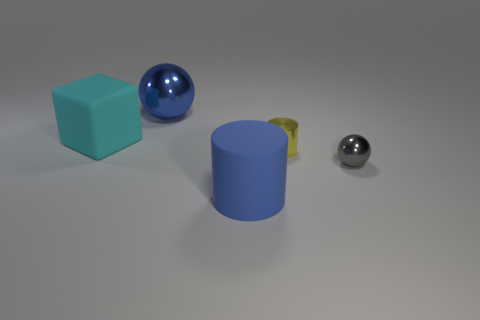Subtract all gray cylinders. Subtract all blue spheres. How many cylinders are left? 2 Add 3 large cyan rubber things. How many objects exist? 8 Subtract all cylinders. How many objects are left? 3 Add 3 big blue rubber cylinders. How many big blue rubber cylinders are left? 4 Add 3 cyan matte balls. How many cyan matte balls exist? 3 Subtract 1 cyan cubes. How many objects are left? 4 Subtract all big shiny balls. Subtract all tiny metal balls. How many objects are left? 3 